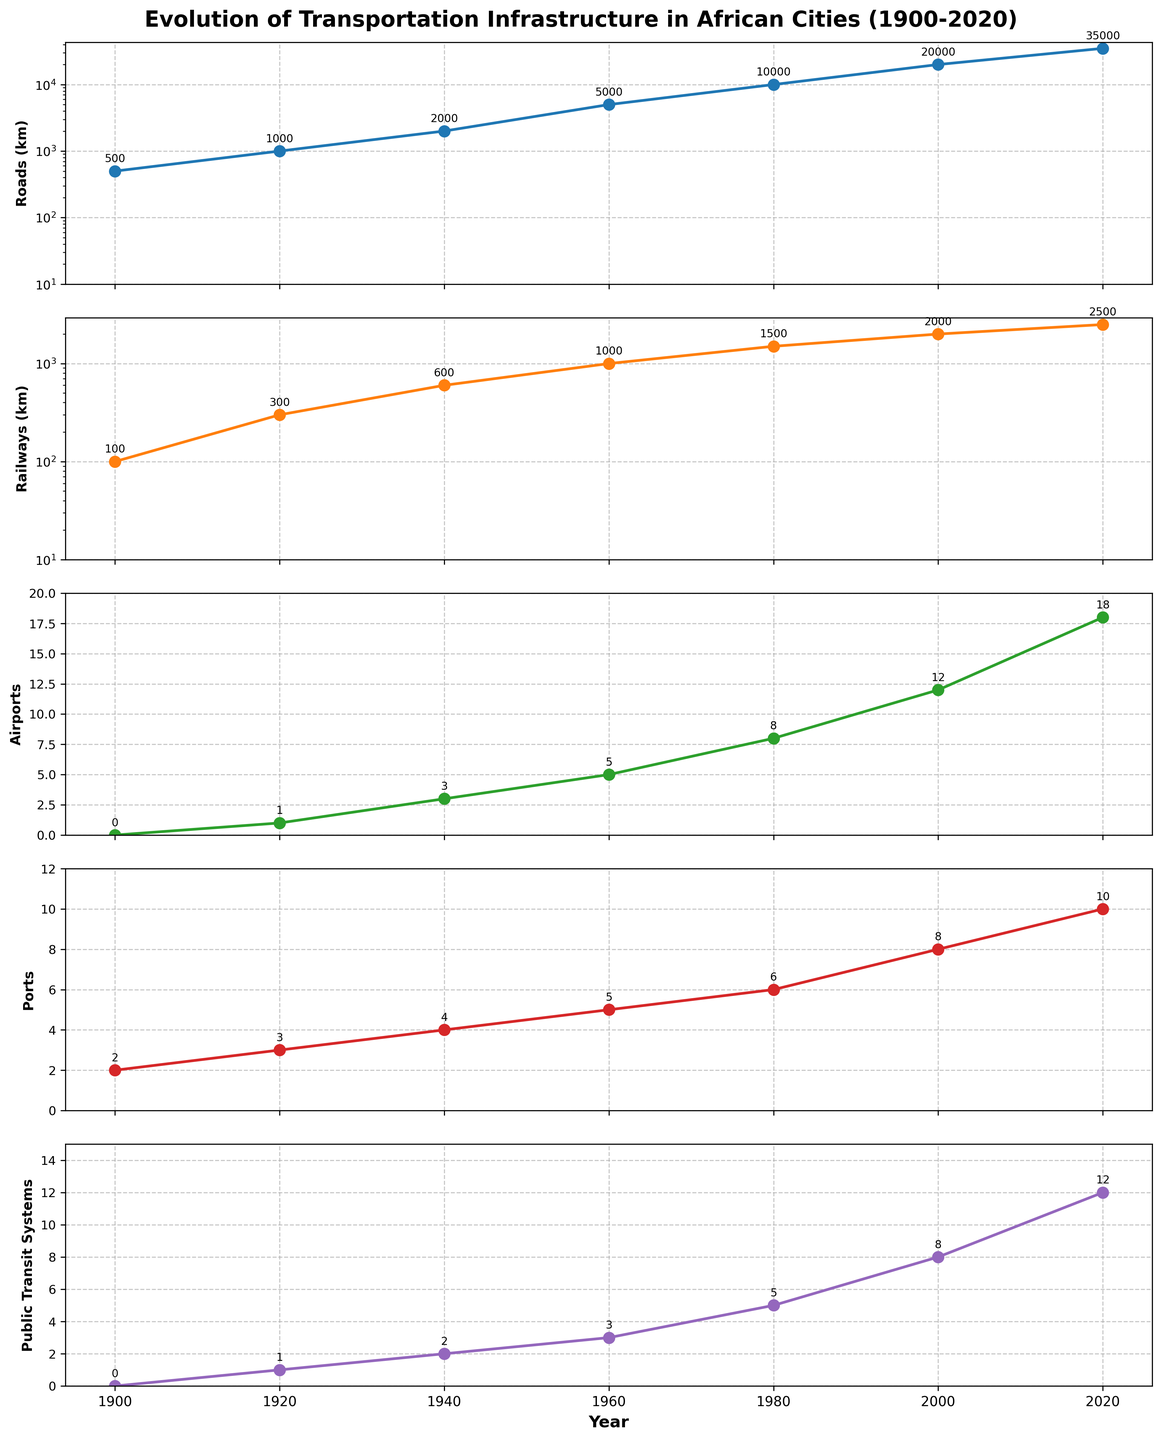How many different categories of transportation infrastructure are shown in the figure? The figure has five separate subplots, each representing a different category: Roads (km), Railways (km), Airports, Ports, and Public Transit Systems.
Answer: 5 What is the title of the figure? The title is displayed at the top of the figure, providing an overview of the theme of the plots. It reads: Evolution of Transportation Infrastructure in African Cities (1900-2020).
Answer: Evolution of Transportation Infrastructure in African Cities (1900-2020) Which year had the highest number of airports? By looking at the third subplot which represents Airports, we see that the year 2020 had the highest number of airports, marked with '18'.
Answer: 2020 What is the trend observed in the Roads (km) subplot from 1900 to 2020? The Roads (km) subplot shows an increasing trend over the years. The values start at 500 km in 1900 and increase to 35,000 km by 2020.
Answer: Increasing How many ports were there in 1960? Referring to the Ports subplot (fourth one), the number of ports in 1960 is annotated as 5.
Answer: 5 Between which two decades did the length of railways (km) experience the highest growth? By examining the Railways (km) subplot, we observe that the growth between 1920 (300 km) and 1940 (600 km) is 300 km, the highest increase compared to other decades.
Answer: 1920 to 1940 Which category of transportation infrastructure had the smallest increase from 1900 to 2020? By comparing the values in all five subplots from 1900 to 2020, we observe that Ports category increased from 2 to 10, making it the smallest increase numerically.
Answer: Ports What is the value difference in Public Transit Systems between 2000 and 2020? The subplot for Public Transit Systems shows values as 8 in 2000 and 12 in 2020. Thus, the difference is 12 - 8 = 4.
Answer: 4 In which decade did the number of airports first exceed 5? By checking the Airports subplot, we see that it first exceeds 5 between 1960 (5 airports) and 1980 (8 airports), so it occurred in the 1980's.
Answer: 1980s 